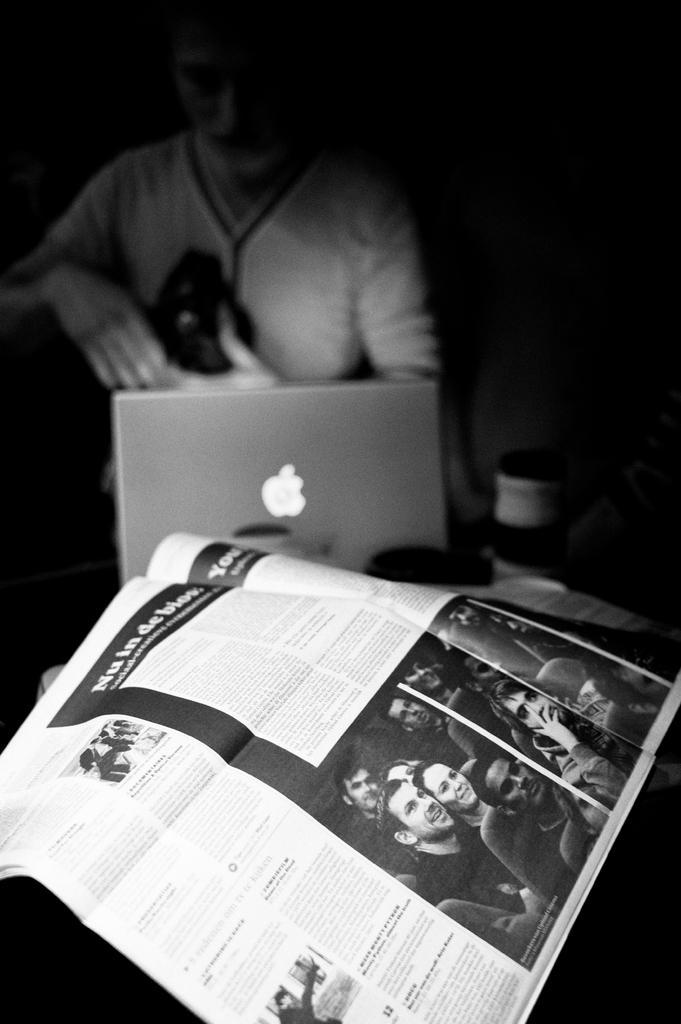Could you give a brief overview of what you see in this image? This is a black and white image and here we can see a person holding an object and there is a laptop, a newspaper and some other objects. 